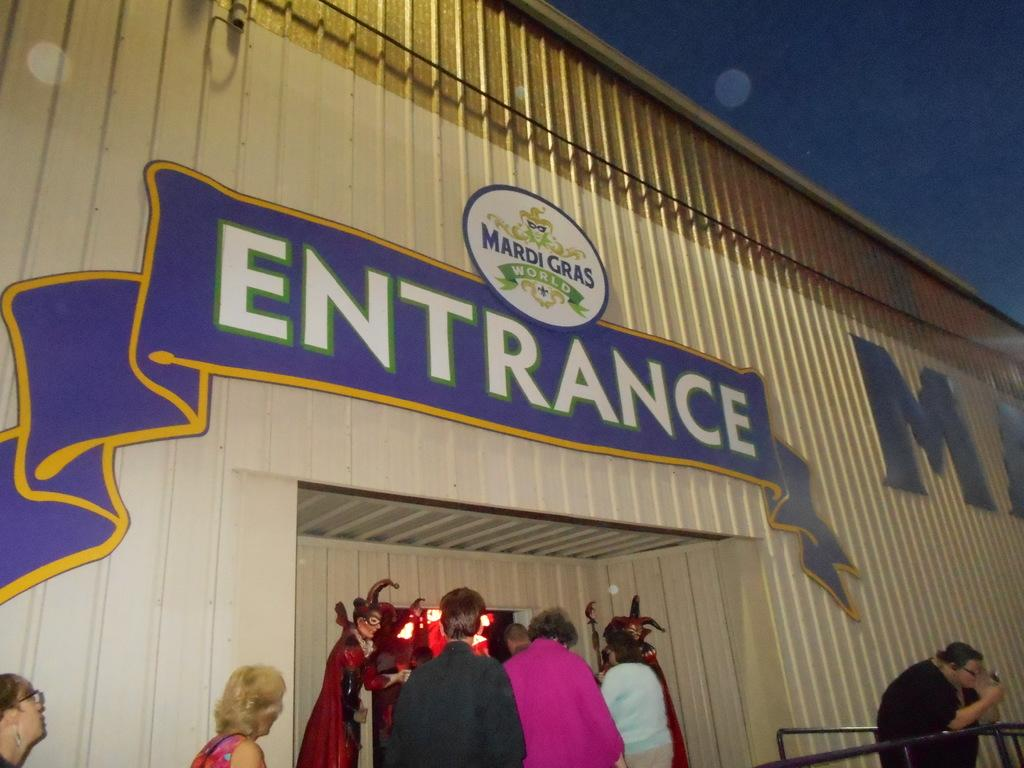<image>
Offer a succinct explanation of the picture presented. The entrance to Mardi Gras World has five people waiting in line. 